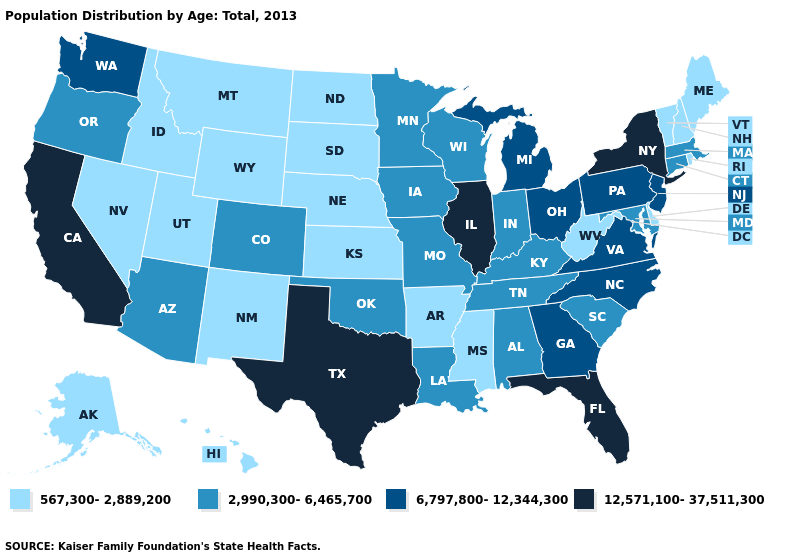Which states have the lowest value in the MidWest?
Answer briefly. Kansas, Nebraska, North Dakota, South Dakota. What is the lowest value in states that border Utah?
Quick response, please. 567,300-2,889,200. Name the states that have a value in the range 567,300-2,889,200?
Write a very short answer. Alaska, Arkansas, Delaware, Hawaii, Idaho, Kansas, Maine, Mississippi, Montana, Nebraska, Nevada, New Hampshire, New Mexico, North Dakota, Rhode Island, South Dakota, Utah, Vermont, West Virginia, Wyoming. Which states have the highest value in the USA?
Short answer required. California, Florida, Illinois, New York, Texas. Among the states that border Idaho , does Utah have the lowest value?
Short answer required. Yes. What is the lowest value in the USA?
Short answer required. 567,300-2,889,200. Does Connecticut have the lowest value in the Northeast?
Quick response, please. No. Name the states that have a value in the range 12,571,100-37,511,300?
Be succinct. California, Florida, Illinois, New York, Texas. Name the states that have a value in the range 567,300-2,889,200?
Write a very short answer. Alaska, Arkansas, Delaware, Hawaii, Idaho, Kansas, Maine, Mississippi, Montana, Nebraska, Nevada, New Hampshire, New Mexico, North Dakota, Rhode Island, South Dakota, Utah, Vermont, West Virginia, Wyoming. Among the states that border Idaho , which have the highest value?
Write a very short answer. Washington. Which states have the highest value in the USA?
Answer briefly. California, Florida, Illinois, New York, Texas. Does Washington have a higher value than Rhode Island?
Give a very brief answer. Yes. What is the highest value in the USA?
Answer briefly. 12,571,100-37,511,300. Which states have the lowest value in the USA?
Concise answer only. Alaska, Arkansas, Delaware, Hawaii, Idaho, Kansas, Maine, Mississippi, Montana, Nebraska, Nevada, New Hampshire, New Mexico, North Dakota, Rhode Island, South Dakota, Utah, Vermont, West Virginia, Wyoming. What is the value of Arizona?
Give a very brief answer. 2,990,300-6,465,700. 